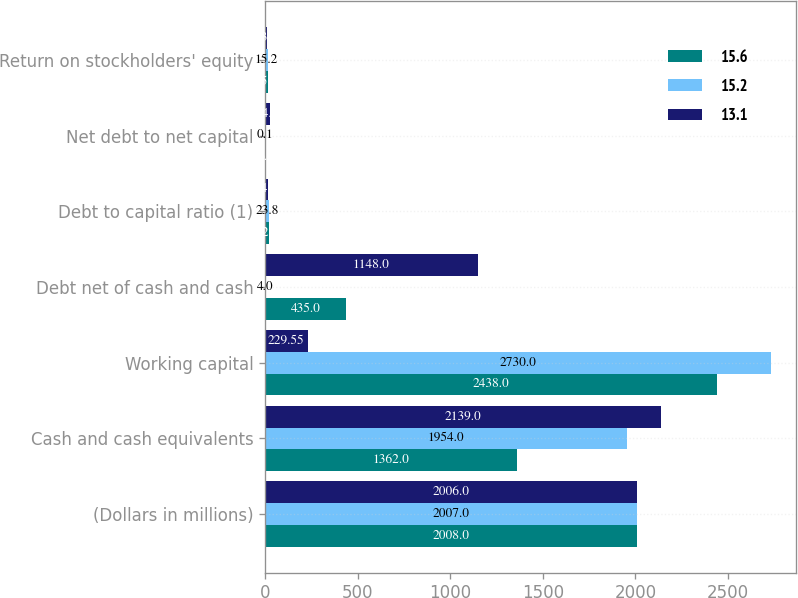Convert chart. <chart><loc_0><loc_0><loc_500><loc_500><stacked_bar_chart><ecel><fcel>(Dollars in millions)<fcel>Cash and cash equivalents<fcel>Working capital<fcel>Debt net of cash and cash<fcel>Debt to capital ratio (1)<fcel>Net debt to net capital<fcel>Return on stockholders' equity<nl><fcel>15.6<fcel>2008<fcel>1362<fcel>2438<fcel>435<fcel>22.7<fcel>6.6<fcel>15.6<nl><fcel>15.2<fcel>2007<fcel>1954<fcel>2730<fcel>4<fcel>23.8<fcel>0.1<fcel>15.2<nl><fcel>13.1<fcel>2006<fcel>2139<fcel>229.55<fcel>1148<fcel>14.4<fcel>24.1<fcel>13.1<nl></chart> 